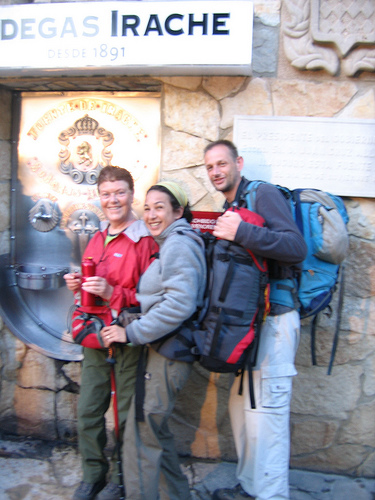<image>
Can you confirm if the man is in front of the sign? Yes. The man is positioned in front of the sign, appearing closer to the camera viewpoint. 